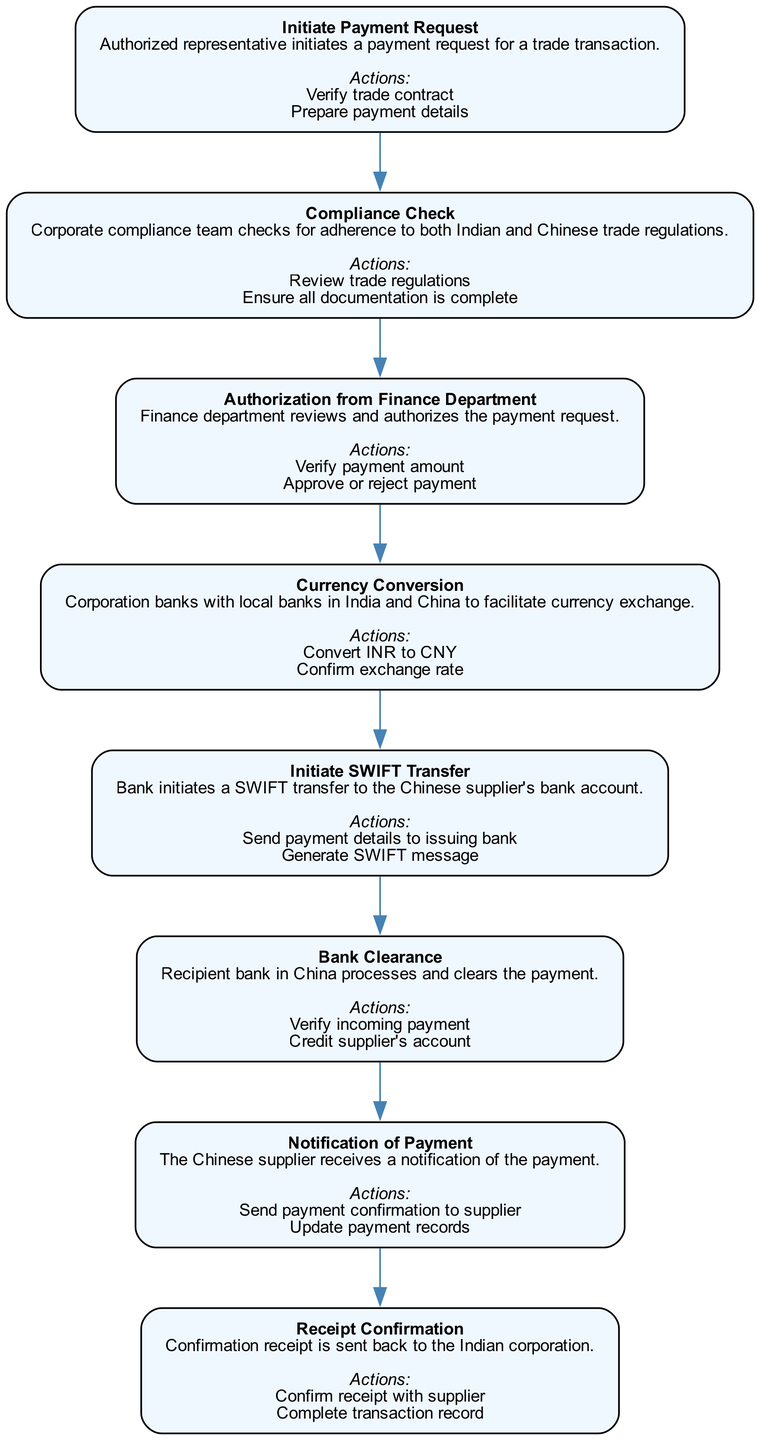What is the first step in the payment processing workflow? The first step is titled "Initiate Payment Request", which indicates it is the starting point of the flowchart. It represents the action taken by the authorized representative to begin the process.
Answer: Initiate Payment Request How many actions are listed under the "Compliance Check"? Under the "Compliance Check" node, there are two specific actions mentioned: "Review trade regulations" and "Ensure all documentation is complete", which can be easily counted.
Answer: 2 What is required to proceed from "Currency Conversion" to "Initiate SWIFT Transfer"? To move from "Currency Conversion" to "Initiate SWIFT Transfer", the action of confirming the exchange rate must be completed, as it logically connects these steps in the workflow.
Answer: Confirm exchange rate What describes the role of the Finance Department in this workflow? The role of the Finance Department is to review and authorize the payment request, which is essential for ensuring that payments are legitimate and approved before processing continues.
Answer: Review and authorize payment request What does the "Receipt Confirmation" step entail? The "Receipt Confirmation" step involves two actions: "Confirm receipt with supplier" and "Complete transaction record", which indicates that this step is about ensuring the transaction is finalized and documented.
Answer: Confirm receipt with supplier What comes after "Bank Clearance" in the workflow? Following "Bank Clearance", the next step in the workflow is "Notification of Payment", indicating the communication to the supplier regarding the payment being processed.
Answer: Notification of Payment What action must be performed to complete the currency conversion? The action that must be performed to complete the currency conversion is "Confirm exchange rate", which is critical for determining the accurate amount to be sent in the converted currency.
Answer: Confirm exchange rate How many nodes are in the workflow diagram? The workflow diagram contains eight distinct nodes, each representing a specific step in the international payment processing workflow from initiation to confirmation.
Answer: 8 What is generated by the bank during the SWIFT transfer? During the SWIFT transfer, the bank generates a "SWIFT message", which is essential for facilitating the electronic transfer of funds to the supplier's bank account in China.
Answer: SWIFT message 